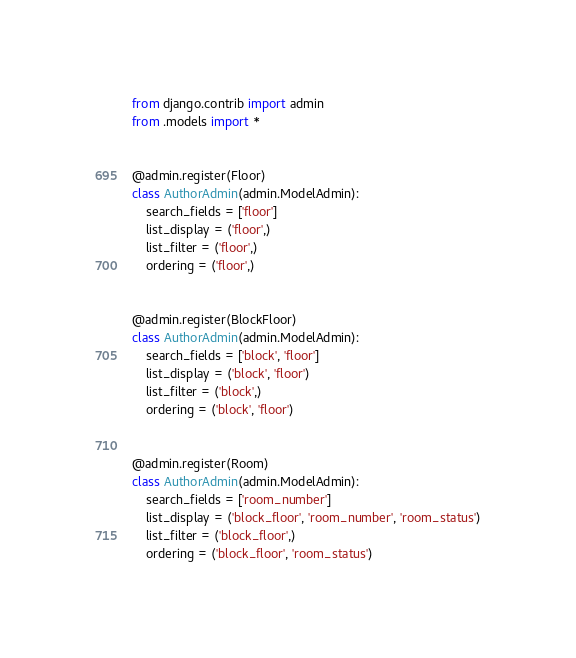Convert code to text. <code><loc_0><loc_0><loc_500><loc_500><_Python_>from django.contrib import admin
from .models import *


@admin.register(Floor)
class AuthorAdmin(admin.ModelAdmin):
    search_fields = ['floor']
    list_display = ('floor',)
    list_filter = ('floor',)
    ordering = ('floor',)


@admin.register(BlockFloor)
class AuthorAdmin(admin.ModelAdmin):
    search_fields = ['block', 'floor']
    list_display = ('block', 'floor')
    list_filter = ('block',)
    ordering = ('block', 'floor')


@admin.register(Room)
class AuthorAdmin(admin.ModelAdmin):
    search_fields = ['room_number']
    list_display = ('block_floor', 'room_number', 'room_status')
    list_filter = ('block_floor',)
    ordering = ('block_floor', 'room_status')
</code> 